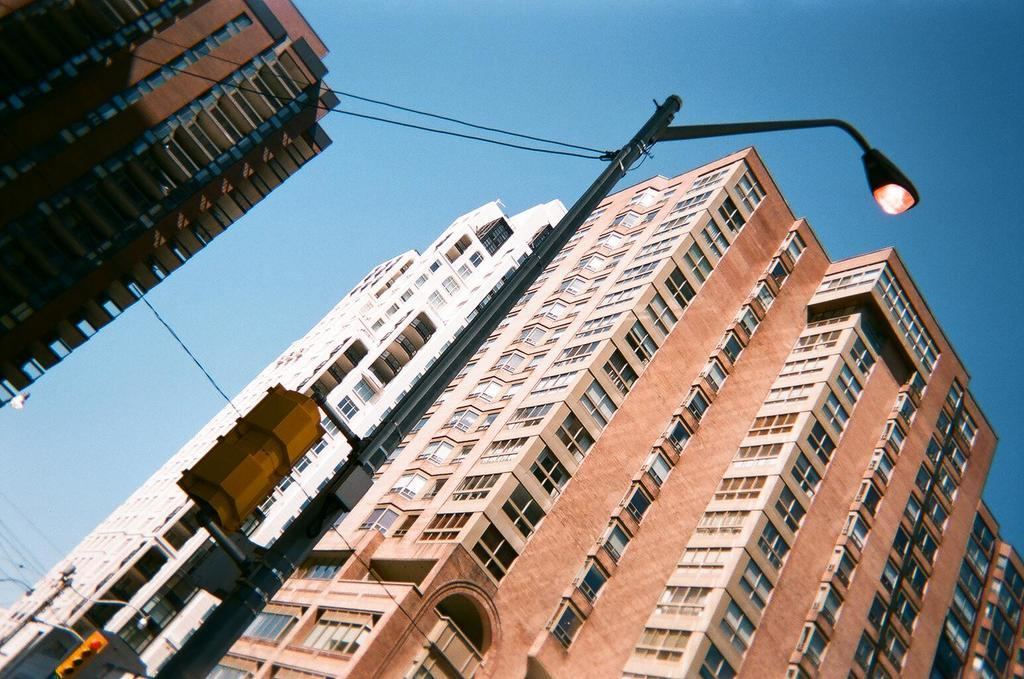What type of structures can be seen in the image? There are buildings in the image. What else can be seen in the image besides the buildings? There are poles with wires and lights visible in the image. What is visible at the top of the image? The sky is visible at the top of the image. What type of yarn is being used to create the fog in the image? There is no yarn or fog present in the image; it features buildings, poles with wires, lights, and a visible sky. What type of earth is visible in the image? The image does not show any specific type of earth; it primarily features buildings, poles with wires, lights, and a visible sky. 